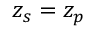<formula> <loc_0><loc_0><loc_500><loc_500>z _ { s } = z _ { p }</formula> 